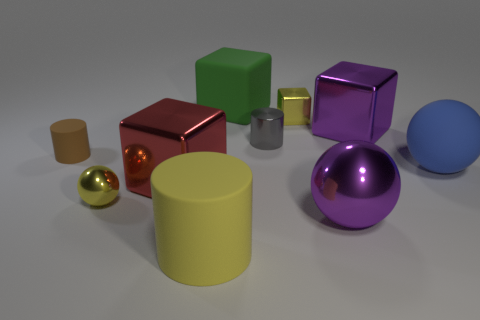Subtract 1 blocks. How many blocks are left? 3 Subtract all balls. How many objects are left? 7 Subtract 1 gray cylinders. How many objects are left? 9 Subtract all purple objects. Subtract all balls. How many objects are left? 5 Add 5 brown rubber cylinders. How many brown rubber cylinders are left? 6 Add 8 yellow metal things. How many yellow metal things exist? 10 